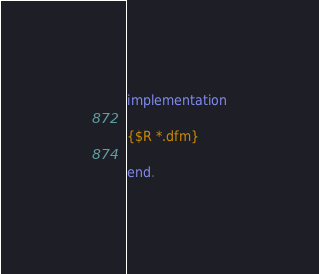Convert code to text. <code><loc_0><loc_0><loc_500><loc_500><_Pascal_>implementation

{$R *.dfm}

end.
</code> 